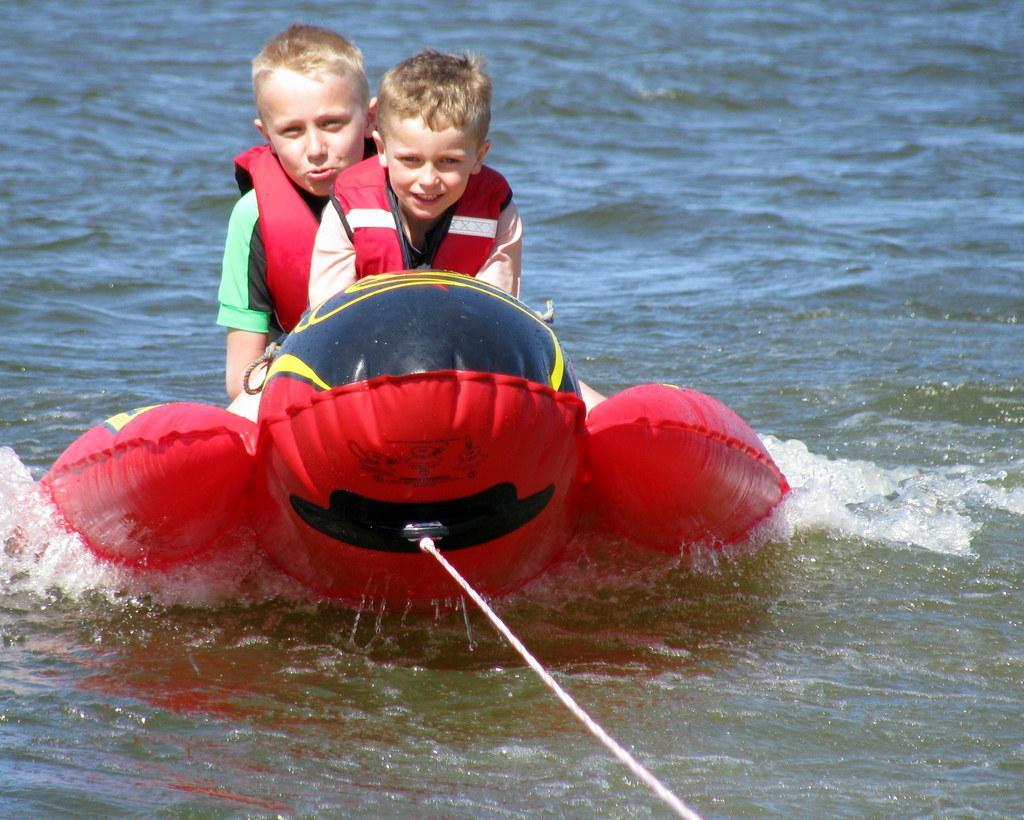Describe this image in one or two sentences. There are two kids sitting on an object which is on water and a white rope tightened to it and the kids wearing red color live jacket. 